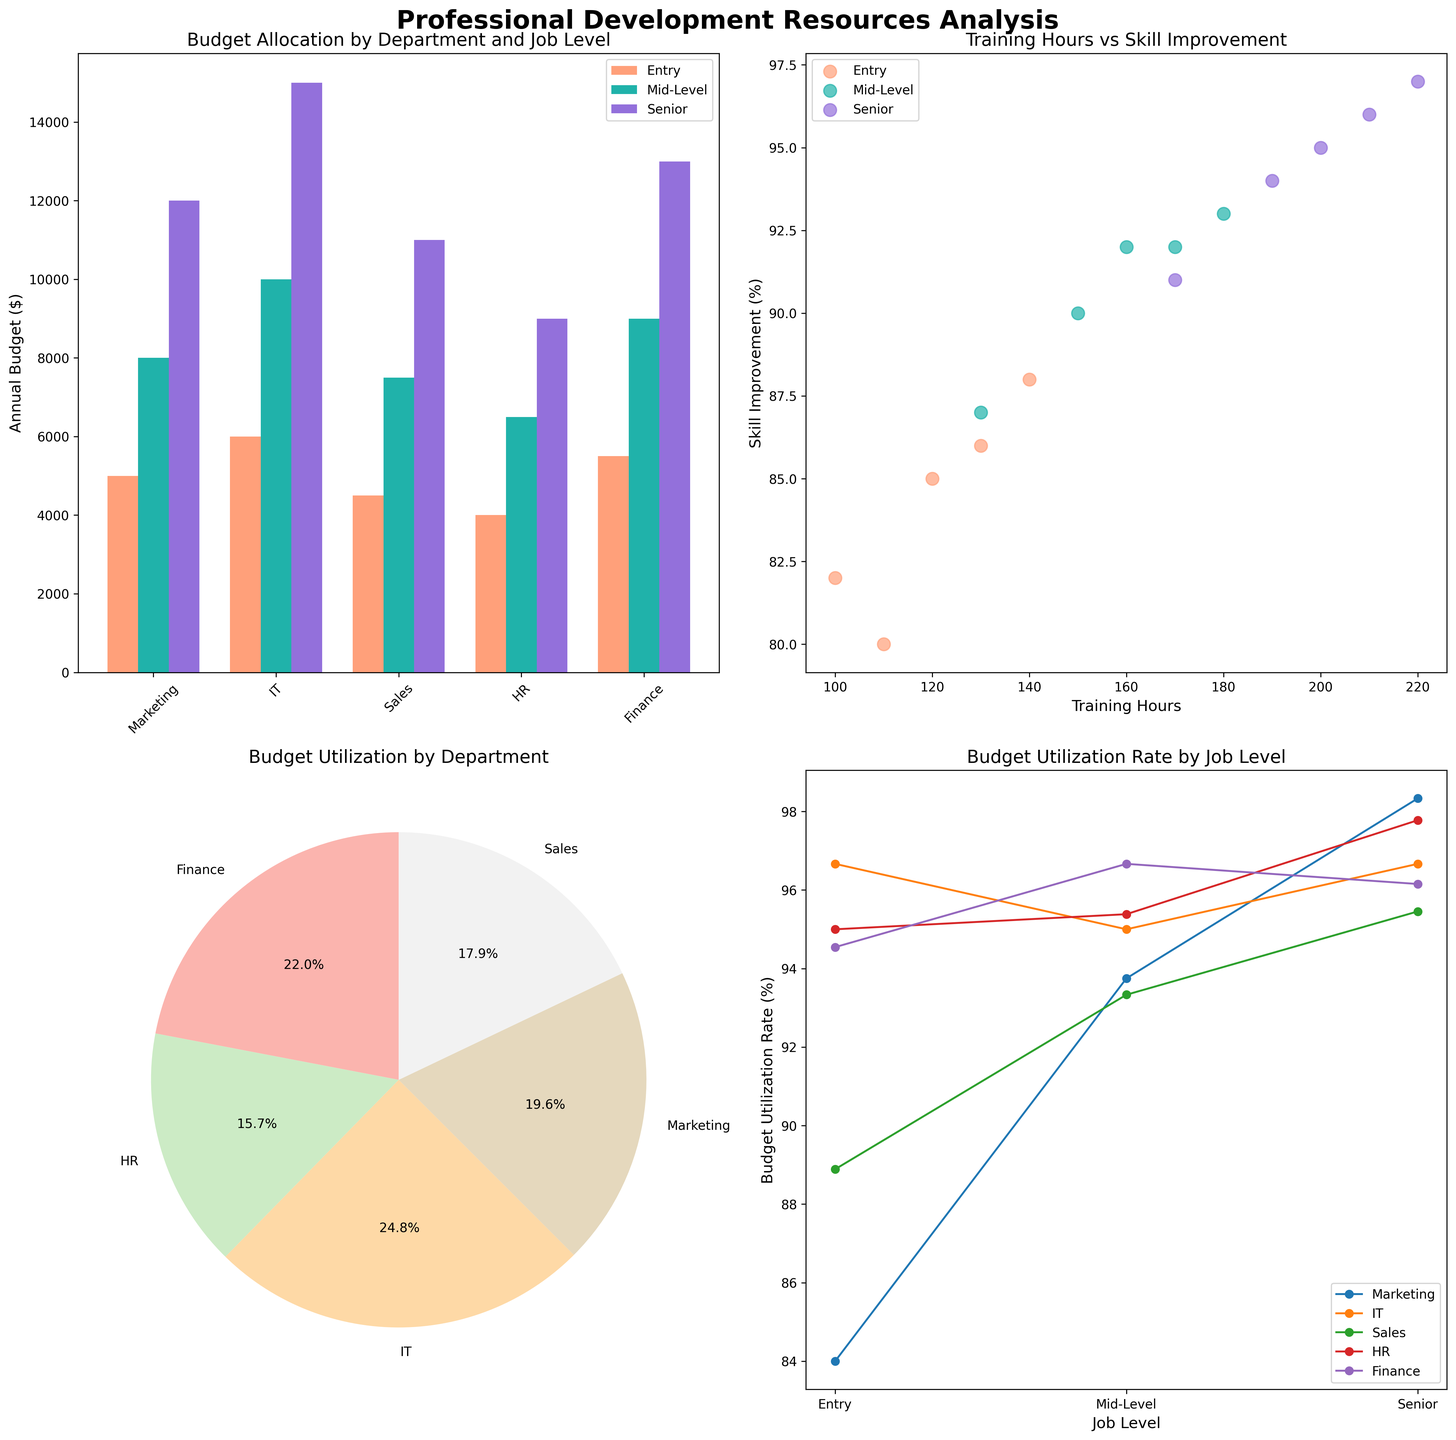What is the total annual budget allocated for the IT department across all job levels? The total annual budget for the IT department is calculated by summing the annual budgets for Entry, Mid-Level, and Senior job levels: 6000+10000+15000 = 31000
Answer: 31000 How many departments are shown in the pie chart for Budget Utilization? The pie chart for Budget Utilization shows the breakdown by department, and you can count the number of labels: Marketing, IT, Sales, HR, Finance, summing to 5 departments
Answer: 5 Which department has the highest budget utilization rate for Senior job levels? By looking at the line plot for Budget Utilization Rate by Job Level, we need to see the Senior job level for each department: Marketing (11800/12000), IT (14500/15000), Sales (10500/11000), HR (8800/9000), Finance (12500/13000). IT department has the highest rate
Answer: IT For the scatter plot, which job level shows the highest skill improvement with the least training hours? Observe the scatter plot to find the Job Level data point closest to the top-left corner (high skill improvement, low training hours). The Entry level has data points showing high skill with comparatively less training hours
Answer: Entry Which department has the largest difference in annual budget between Entry and Senior job levels? Check the bar plot for Budget Allocation by Department. Calculate the differences: Marketing (12000-5000=7000), IT (15000-6000=9000), Sales (11000-4500=6500), HR (9000-4000=5000), Finance (13000-5500=7500). IT has the largest difference
Answer: IT Considering all departments, what is the average training hours for Mid-Level employees? Extract the Mid-Level training hours from the data: Marketing (160), IT (180), Sales (150), HR (130), Finance (170). The average = (160+180+150+130+170)/5 = 158
Answer: 158 Which department contributes the highest proportion of utilized budget in the pie chart? In the pie chart for Budget Utilization by Department, observe the segment with the largest percentage label. This is IT department with the largest segment by proportion
Answer: IT In the line plot, do any departments have decreasing budget utilization rates as job levels increase? Analyze the line plot for Budget Utilization Rate by Job Level. No department shows a decreasing trend as job levels increase; all lines either increase or remain approximately stable
Answer: No How many job levels are represented in the scatter plot comparing Training Hours and Skill Improvement? The legend in the scatter plot indicates 3 different job levels being represented: Entry, Mid-Level, and Senior
Answer: 3 